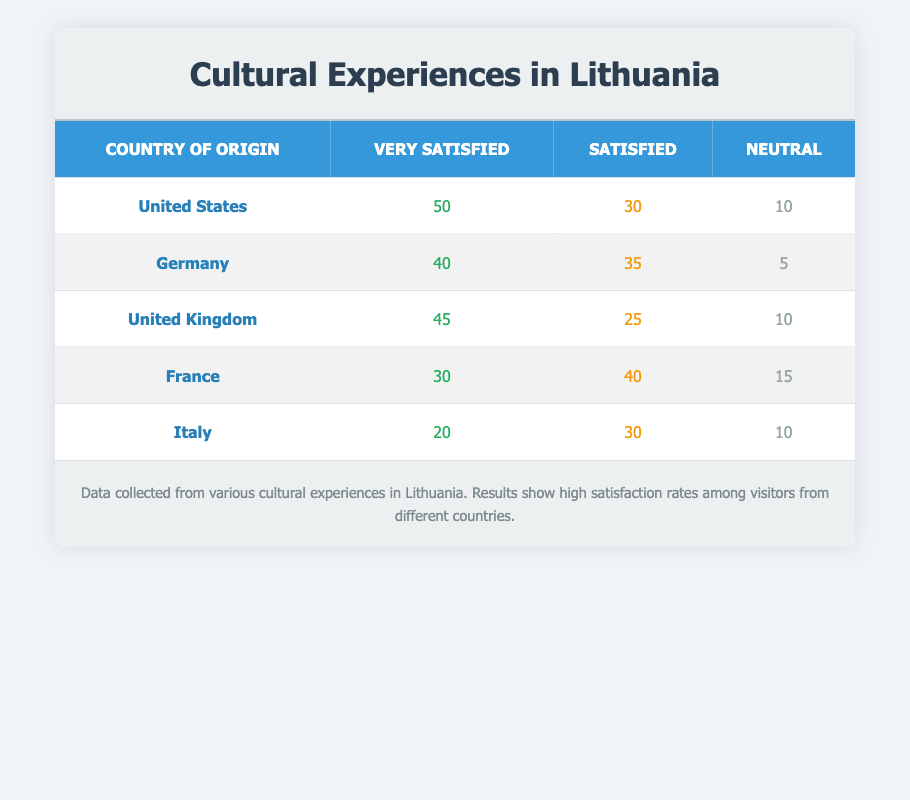What is the highest satisfaction rating among visitors from the United States? From the table, we can see that the highest satisfaction rating for visitors from the United States is "Very Satisfied," with a count of 50.
Answer: Very Satisfied How many visitors from Germany were Neutral about their experience? The table indicates that 5 visitors from Germany reported being Neutral about their cultural experiences in Lithuania.
Answer: 5 Which country had the lowest count of Very Satisfied visitors? By examining the counts for Very Satisfied visitors, Italy had the lowest with a count of 20, compared to other countries.
Answer: Italy What is the total number of Satisfied visitors from France and Germany? We find the Satisfied counts for both France and Germany: France has 40 and Germany has 35. Adding these gives us 40 + 35 = 75.
Answer: 75 Is it true that the United Kingdom had more Very Satisfied visitors than Italy? Yes, the United Kingdom had 45 Very Satisfied visitors, while Italy had only 20, making the statement true.
Answer: Yes What percentage of visitors from the United States were either Very Satisfied or Satisfied? The United States has 50 Very Satisfied and 30 Satisfied visitors, totaling 80 visitors. The total visitors from the US (which also includes Neutral) is 50 + 30 + 10 = 90. The percentage is (80/90) * 100 = 88.89%.
Answer: 88.89% How does the number of Satisfied visitors from France compare to the total Neutral visitors across all countries? France has 40 Satisfied visitors. To find the total Neutral visitors, we add them up: 10 (US) + 5 (Germany) + 10 (UK) + 15 (France) + 10 (Italy) = 50. Since 40 is less than 50, the comparison indicates that France's Satisfied count is less.
Answer: Less Which country had the highest overall satisfaction when considering all categories? To find the overall satisfaction, sum each country's counts: United States (90), Germany (80), United Kingdom (80), France (85), and Italy (60). The United States leads with a total of 90, indicating the highest overall satisfaction.
Answer: United States 